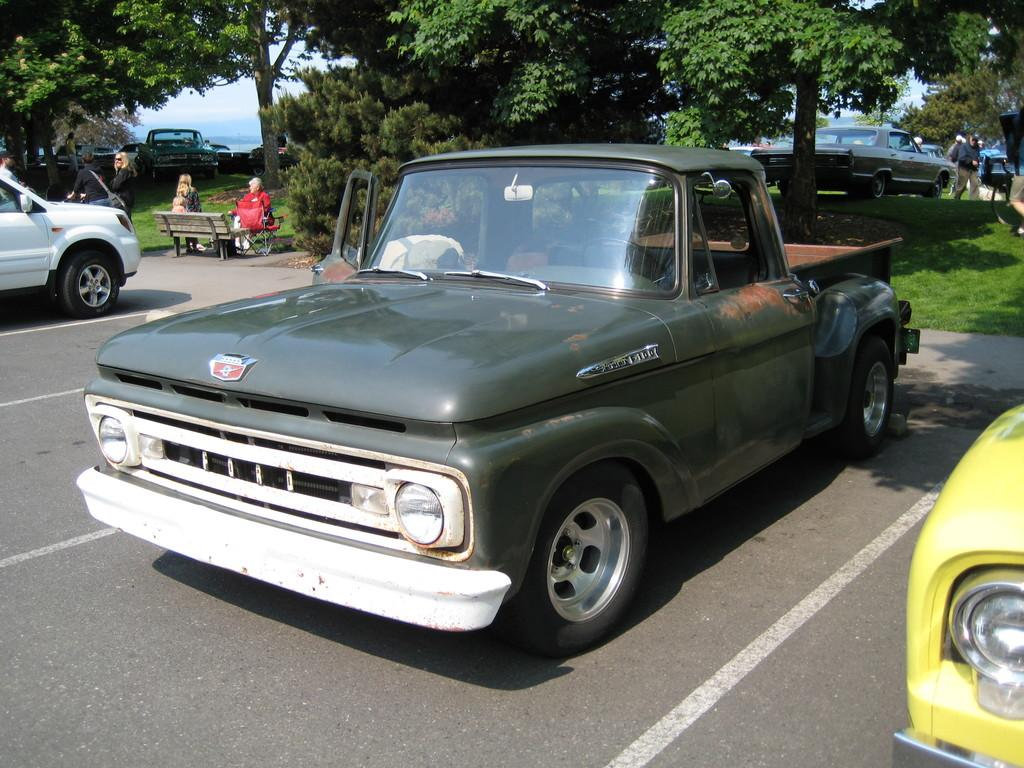What type of vehicles can be seen in the image? There are cars in the image. Who or what else is present in the image? There are people in the image. What type of seating is available in the image? There is a bench in the image. What type of vegetation is present in the image? There are trees and grass in the image. What part of the natural environment is visible in the image? The sky is visible in the image. What type of nut can be seen on the bench in the image? There is no nut present on the bench in the image. 